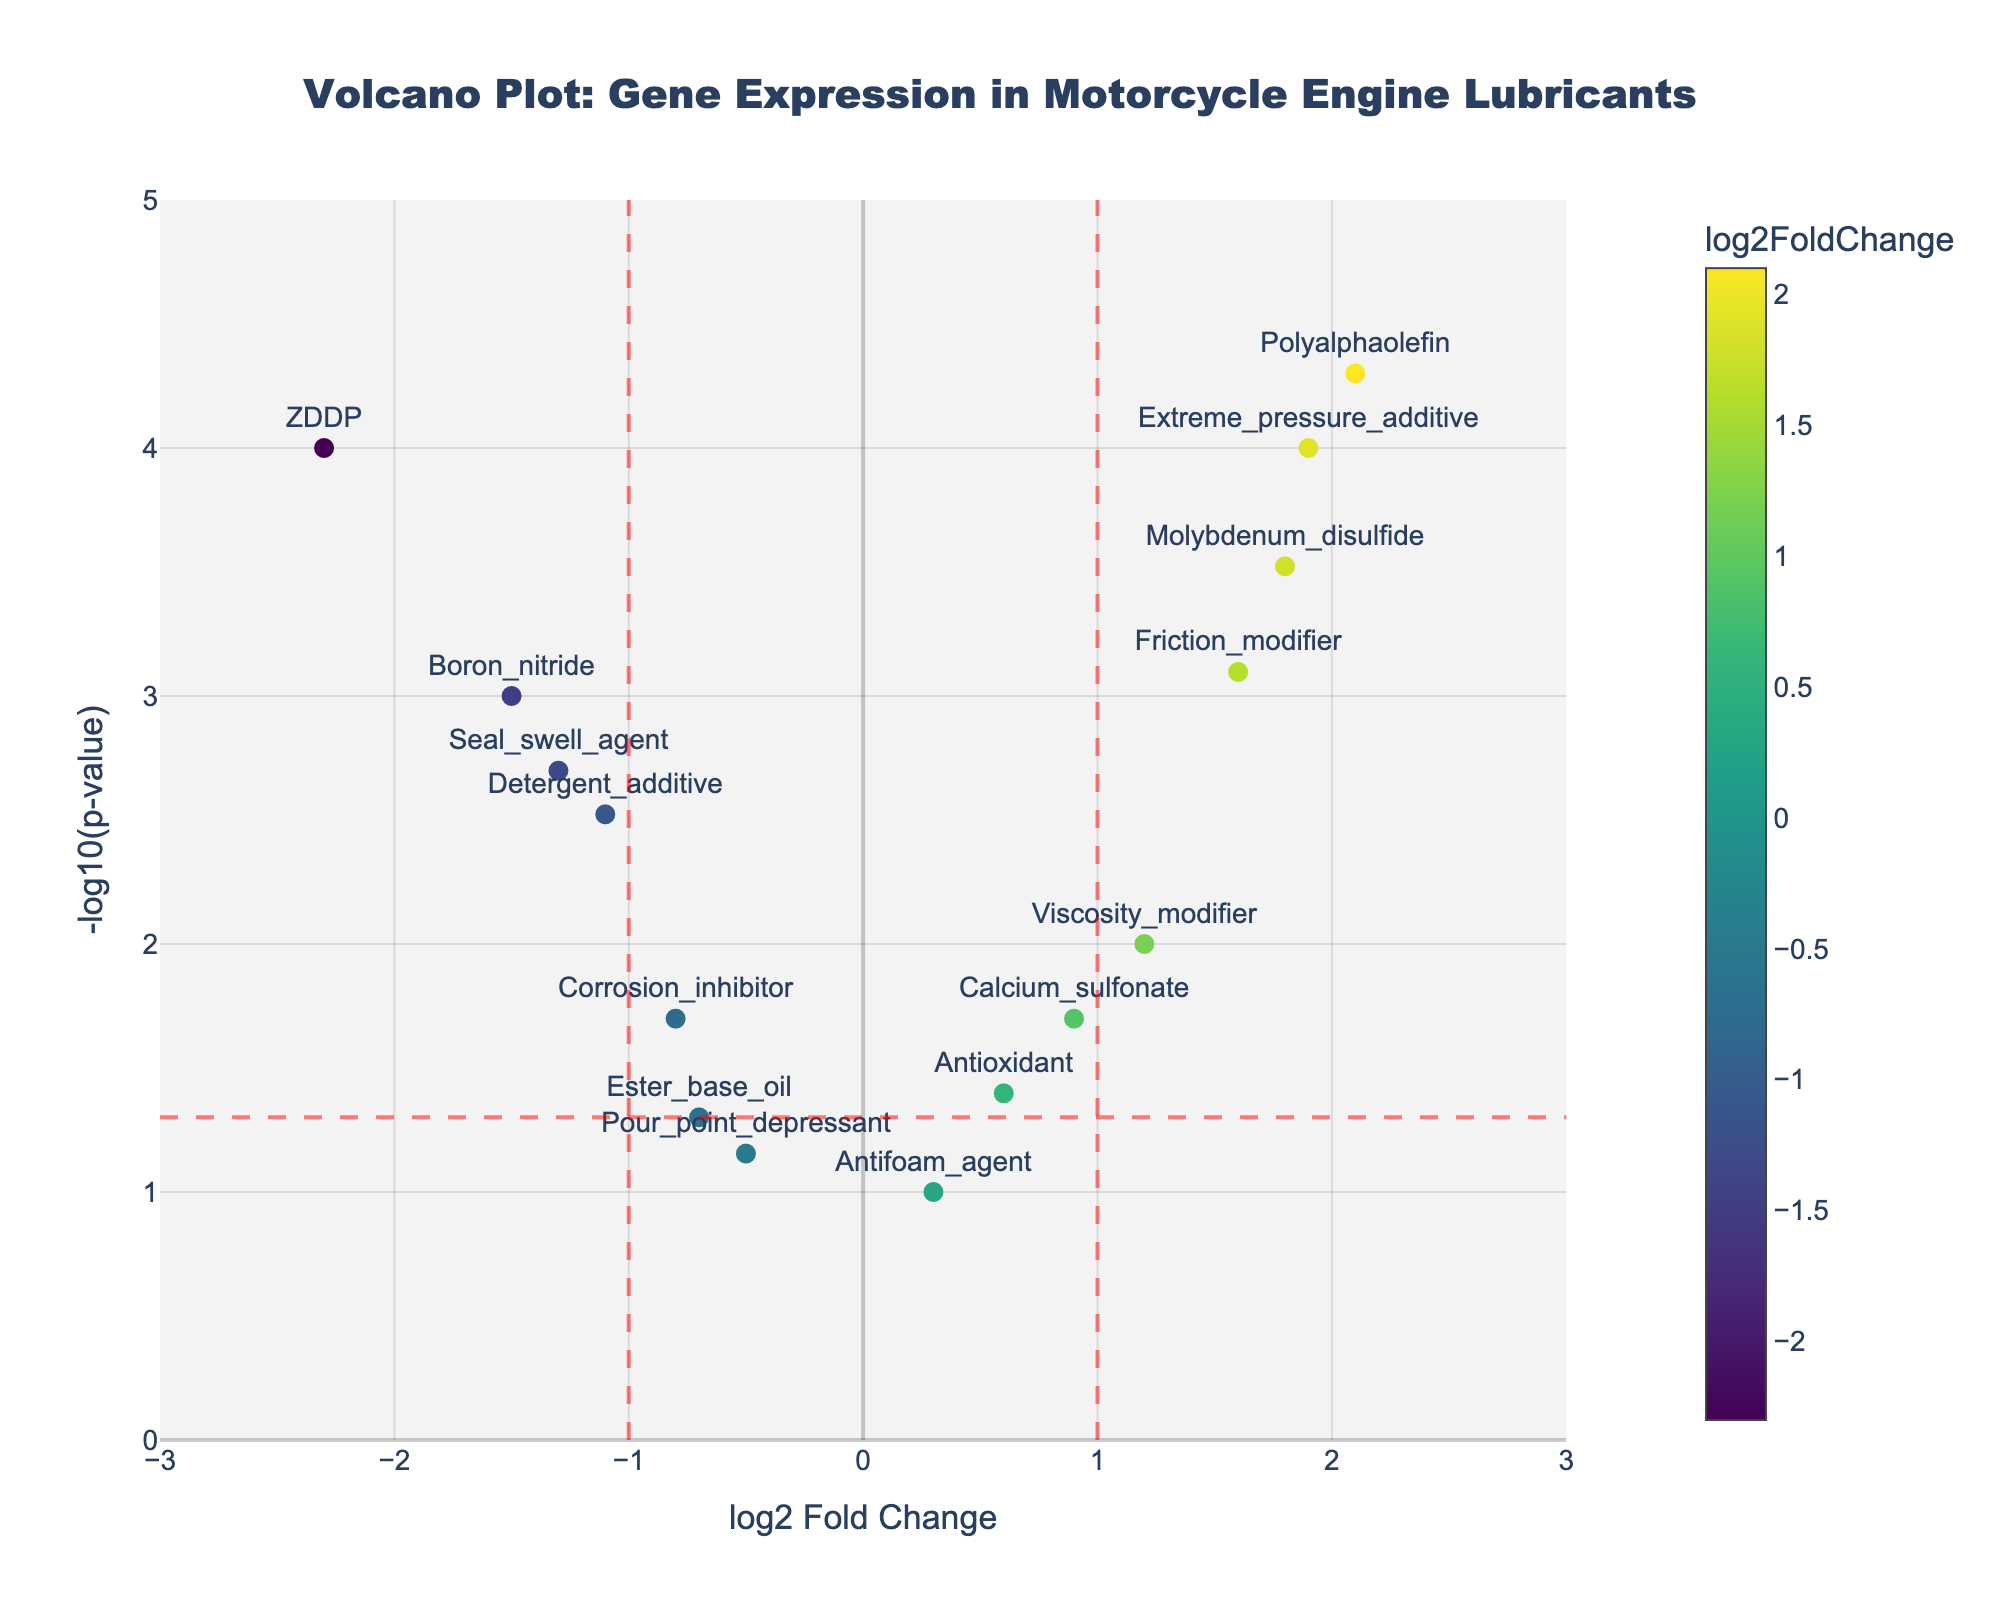What is the title of the plot? The title of the plot is displayed prominently at the top center of the figure, which reads "Volcano Plot: Gene Expression in Motorcycle Engine Lubricants."
Answer: Volcano Plot: Gene Expression in Motorcycle Engine Lubricants What are the x-axis and y-axis labels? The x-axis is labeled "log2 Fold Change" and the y-axis is labeled "-log10(p-value)," as indicated at their respective positions on the figure.
Answer: log2 Fold Change; -log10(p-value) How many genes have a p-value less than 0.05? To determine the number of genes with a p-value less than 0.05, look at the points above the horizontal red-dashed line (which represents the threshold of -log10(0.05)).
Answer: 10 Which gene has the highest log2 Fold Change? The gene with the highest log2 Fold Change is the one farthest to the right on the x-axis. Here, it is the "Polyalphaolefin" gene.
Answer: Polyalphaolefin Which gene has the most significant p-value, and how can you tell? The gene with the most significant p-value is the one highest on the y-axis. In the plot, the "Polyalphaolefin" gene has the highest -log10(p-value), indicating it has the most significant p-value.
Answer: Polyalphaolefin Which genes are considered significantly upregulated? Significantly upregulated genes are those to the right of the vertical red-dashed line at log2 Fold Change = 1 and above the horizontal red-dashed line at -log10(p-value) = 1.3 (p-value < 0.05). The genes are "Polyalphaolefin," "Molybdenum_disulfide," "Extreme_pressure_additive," and "Friction_modifier."
Answer: Polyalphaolefin, Molybdenum_disulfide, Extreme_pressure_additive, Friction_modifier Which gene has the lowest log2 Fold Change, and what does it signify? The gene with the lowest log2 Fold Change is the one farthest to the left on the x-axis, which is "ZDDP." It signifies the largest downregulation.
Answer: ZDDP Are there any genes that are not significantly differentially expressed? Genes with p-values > 0.05 will have a -log10(p-value) < 1.3, representing non-significant differential expression. The genes are "Ester_base_oil," "Antioxidant," "Pour_point_depressant," and "Antifoam_agent."
Answer: Ester_base_oil, Antioxidant, Pour_point_depressant, Antifoam_agent Which genes are significantly downregulated? Significantly downregulated genes are to the left of the vertical red-dashed line at log2 Fold Change = -1 and above the horizontal red-dashed line at -log10(p-value) = 1.3 (p-value < 0.05). The genes are "ZDDP," "Boron_nitride," "Detergent_additive," and "Seal_swell_agent."
Answer: ZDDP, Boron_nitride, Detergent_additive, Seal_swell_agent 